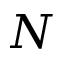<formula> <loc_0><loc_0><loc_500><loc_500>N</formula> 